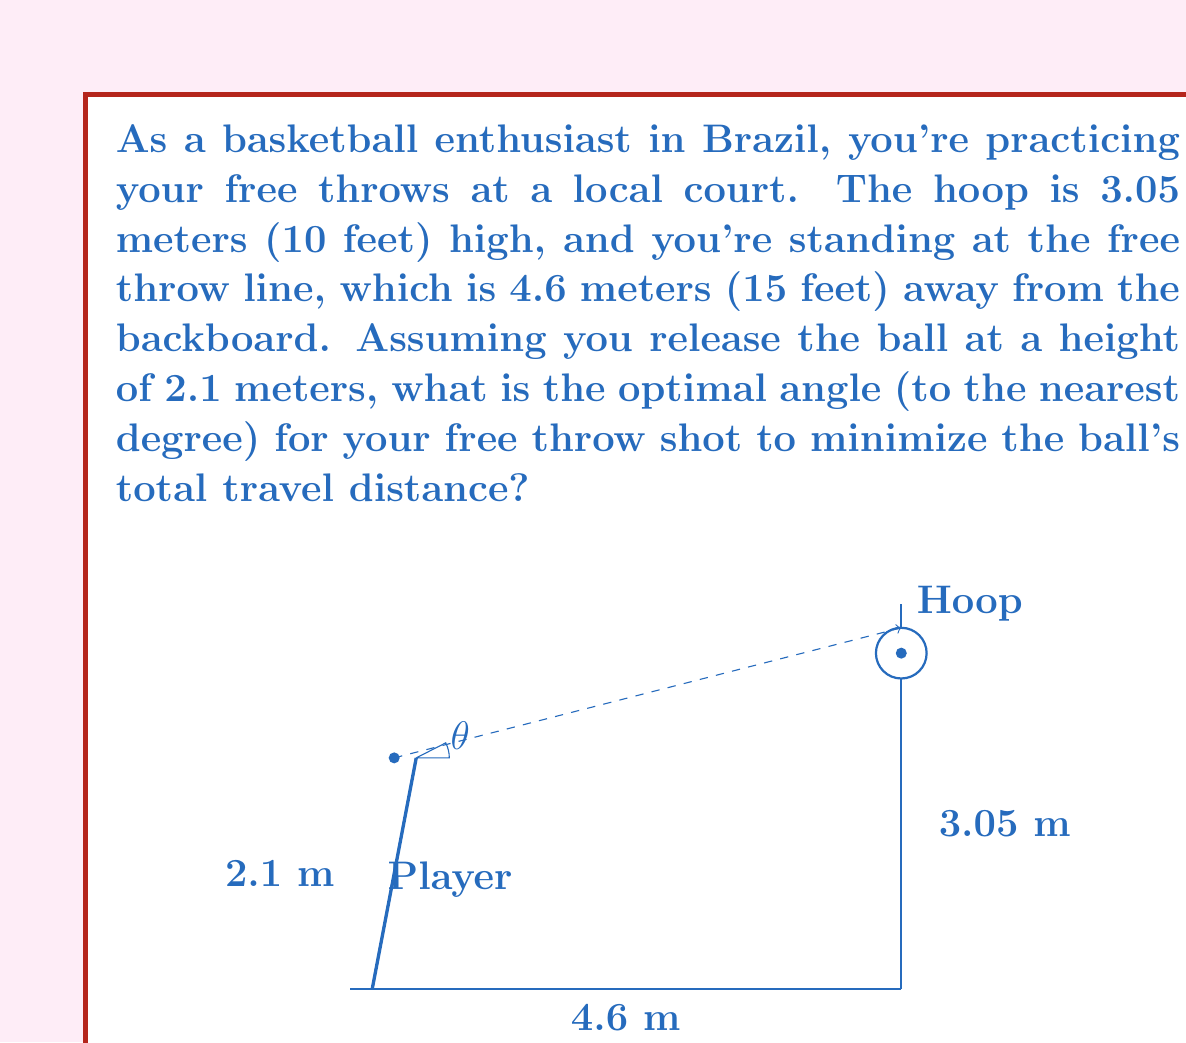Show me your answer to this math problem. To solve this problem, we'll use trigonometry and calculus to find the optimal angle. Let's break it down step-by-step:

1) Let $\theta$ be the angle of the shot from the horizontal.

2) The horizontal distance to the hoop is 4.6 m, and the vertical distance from release point to hoop is 3.05 m - 2.1 m = 0.95 m.

3) The path of the ball can be modeled as a parabola. The distance (d) the ball travels is given by:

   $$d = \frac{4.6}{\cos\theta}$$

4) To minimize d, we need to maximize $\cos\theta$. However, we also need to ensure the ball reaches the hoop. The condition for this is:

   $$\tan\theta = \frac{0.95 + 4.6\tan\theta}{4.6}$$

5) Solving this equation:
   
   $$0.95 = 4.6\tan\theta - 4.6\tan\theta = 0.95$$

   This confirms that any angle satisfying this condition will result in the ball reaching the hoop.

6) Now, we want to minimize d, which is equivalent to maximizing $\cos\theta$. The maximum value of $\cos\theta$ occurs when $\theta$ is as small as possible while still satisfying the condition in step 4.

7) Using the tangent formula from step 4:

   $$\tan\theta = \frac{0.95}{4.6} \approx 0.2065$$

8) Taking the inverse tangent:

   $$\theta = \arctan(0.2065) \approx 11.67°$$

9) Rounding to the nearest degree, we get 12°.
Answer: $12°$ 